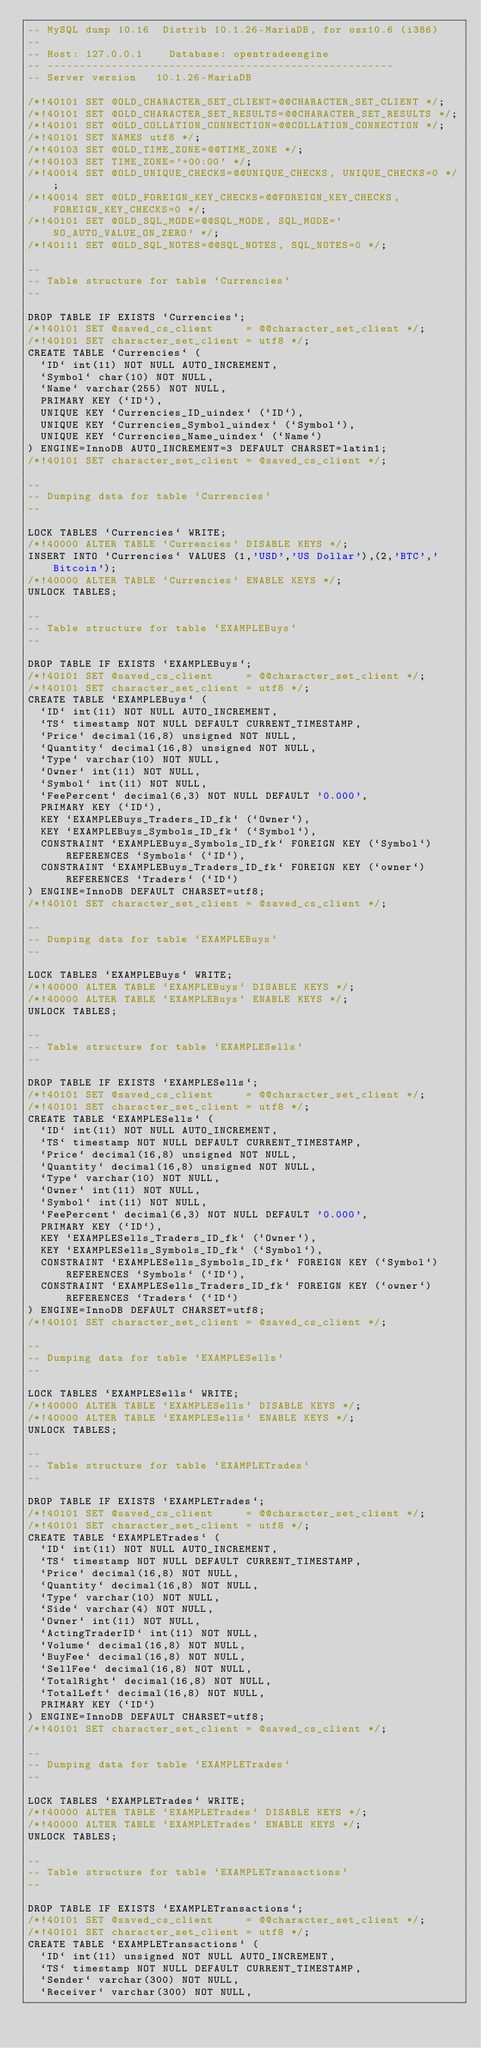Convert code to text. <code><loc_0><loc_0><loc_500><loc_500><_SQL_>-- MySQL dump 10.16  Distrib 10.1.26-MariaDB, for osx10.6 (i386)
--
-- Host: 127.0.0.1    Database: opentradeengine
-- ------------------------------------------------------
-- Server version	10.1.26-MariaDB

/*!40101 SET @OLD_CHARACTER_SET_CLIENT=@@CHARACTER_SET_CLIENT */;
/*!40101 SET @OLD_CHARACTER_SET_RESULTS=@@CHARACTER_SET_RESULTS */;
/*!40101 SET @OLD_COLLATION_CONNECTION=@@COLLATION_CONNECTION */;
/*!40101 SET NAMES utf8 */;
/*!40103 SET @OLD_TIME_ZONE=@@TIME_ZONE */;
/*!40103 SET TIME_ZONE='+00:00' */;
/*!40014 SET @OLD_UNIQUE_CHECKS=@@UNIQUE_CHECKS, UNIQUE_CHECKS=0 */;
/*!40014 SET @OLD_FOREIGN_KEY_CHECKS=@@FOREIGN_KEY_CHECKS, FOREIGN_KEY_CHECKS=0 */;
/*!40101 SET @OLD_SQL_MODE=@@SQL_MODE, SQL_MODE='NO_AUTO_VALUE_ON_ZERO' */;
/*!40111 SET @OLD_SQL_NOTES=@@SQL_NOTES, SQL_NOTES=0 */;

--
-- Table structure for table `Currencies`
--

DROP TABLE IF EXISTS `Currencies`;
/*!40101 SET @saved_cs_client     = @@character_set_client */;
/*!40101 SET character_set_client = utf8 */;
CREATE TABLE `Currencies` (
  `ID` int(11) NOT NULL AUTO_INCREMENT,
  `Symbol` char(10) NOT NULL,
  `Name` varchar(255) NOT NULL,
  PRIMARY KEY (`ID`),
  UNIQUE KEY `Currencies_ID_uindex` (`ID`),
  UNIQUE KEY `Currencies_Symbol_uindex` (`Symbol`),
  UNIQUE KEY `Currencies_Name_uindex` (`Name`)
) ENGINE=InnoDB AUTO_INCREMENT=3 DEFAULT CHARSET=latin1;
/*!40101 SET character_set_client = @saved_cs_client */;

--
-- Dumping data for table `Currencies`
--

LOCK TABLES `Currencies` WRITE;
/*!40000 ALTER TABLE `Currencies` DISABLE KEYS */;
INSERT INTO `Currencies` VALUES (1,'USD','US Dollar'),(2,'BTC','Bitcoin');
/*!40000 ALTER TABLE `Currencies` ENABLE KEYS */;
UNLOCK TABLES;

--
-- Table structure for table `EXAMPLEBuys`
--

DROP TABLE IF EXISTS `EXAMPLEBuys`;
/*!40101 SET @saved_cs_client     = @@character_set_client */;
/*!40101 SET character_set_client = utf8 */;
CREATE TABLE `EXAMPLEBuys` (
  `ID` int(11) NOT NULL AUTO_INCREMENT,
  `TS` timestamp NOT NULL DEFAULT CURRENT_TIMESTAMP,
  `Price` decimal(16,8) unsigned NOT NULL,
  `Quantity` decimal(16,8) unsigned NOT NULL,
  `Type` varchar(10) NOT NULL,
  `Owner` int(11) NOT NULL,
  `Symbol` int(11) NOT NULL,
  `FeePercent` decimal(6,3) NOT NULL DEFAULT '0.000',
  PRIMARY KEY (`ID`),
  KEY `EXAMPLEBuys_Traders_ID_fk` (`Owner`),
  KEY `EXAMPLEBuys_Symbols_ID_fk` (`Symbol`),
  CONSTRAINT `EXAMPLEBuys_Symbols_ID_fk` FOREIGN KEY (`Symbol`) REFERENCES `Symbols` (`ID`),
  CONSTRAINT `EXAMPLEBuys_Traders_ID_fk` FOREIGN KEY (`owner`) REFERENCES `Traders` (`ID`)
) ENGINE=InnoDB DEFAULT CHARSET=utf8;
/*!40101 SET character_set_client = @saved_cs_client */;

--
-- Dumping data for table `EXAMPLEBuys`
--

LOCK TABLES `EXAMPLEBuys` WRITE;
/*!40000 ALTER TABLE `EXAMPLEBuys` DISABLE KEYS */;
/*!40000 ALTER TABLE `EXAMPLEBuys` ENABLE KEYS */;
UNLOCK TABLES;

--
-- Table structure for table `EXAMPLESells`
--

DROP TABLE IF EXISTS `EXAMPLESells`;
/*!40101 SET @saved_cs_client     = @@character_set_client */;
/*!40101 SET character_set_client = utf8 */;
CREATE TABLE `EXAMPLESells` (
  `ID` int(11) NOT NULL AUTO_INCREMENT,
  `TS` timestamp NOT NULL DEFAULT CURRENT_TIMESTAMP,
  `Price` decimal(16,8) unsigned NOT NULL,
  `Quantity` decimal(16,8) unsigned NOT NULL,
  `Type` varchar(10) NOT NULL,
  `Owner` int(11) NOT NULL,
  `Symbol` int(11) NOT NULL,
  `FeePercent` decimal(6,3) NOT NULL DEFAULT '0.000',
  PRIMARY KEY (`ID`),
  KEY `EXAMPLESells_Traders_ID_fk` (`Owner`),
  KEY `EXAMPLESells_Symbols_ID_fk` (`Symbol`),
  CONSTRAINT `EXAMPLESells_Symbols_ID_fk` FOREIGN KEY (`Symbol`) REFERENCES `Symbols` (`ID`),
  CONSTRAINT `EXAMPLESells_Traders_ID_fk` FOREIGN KEY (`owner`) REFERENCES `Traders` (`ID`)
) ENGINE=InnoDB DEFAULT CHARSET=utf8;
/*!40101 SET character_set_client = @saved_cs_client */;

--
-- Dumping data for table `EXAMPLESells`
--

LOCK TABLES `EXAMPLESells` WRITE;
/*!40000 ALTER TABLE `EXAMPLESells` DISABLE KEYS */;
/*!40000 ALTER TABLE `EXAMPLESells` ENABLE KEYS */;
UNLOCK TABLES;

--
-- Table structure for table `EXAMPLETrades`
--

DROP TABLE IF EXISTS `EXAMPLETrades`;
/*!40101 SET @saved_cs_client     = @@character_set_client */;
/*!40101 SET character_set_client = utf8 */;
CREATE TABLE `EXAMPLETrades` (
  `ID` int(11) NOT NULL AUTO_INCREMENT,
  `TS` timestamp NOT NULL DEFAULT CURRENT_TIMESTAMP,
  `Price` decimal(16,8) NOT NULL,
  `Quantity` decimal(16,8) NOT NULL,
  `Type` varchar(10) NOT NULL,
  `Side` varchar(4) NOT NULL,
  `Owner` int(11) NOT NULL,
  `ActingTraderID` int(11) NOT NULL,
  `Volume` decimal(16,8) NOT NULL,
  `BuyFee` decimal(16,8) NOT NULL,
  `SellFee` decimal(16,8) NOT NULL,
  `TotalRight` decimal(16,8) NOT NULL,
  `TotalLeft` decimal(16,8) NOT NULL,
  PRIMARY KEY (`ID`)
) ENGINE=InnoDB DEFAULT CHARSET=utf8;
/*!40101 SET character_set_client = @saved_cs_client */;

--
-- Dumping data for table `EXAMPLETrades`
--

LOCK TABLES `EXAMPLETrades` WRITE;
/*!40000 ALTER TABLE `EXAMPLETrades` DISABLE KEYS */;
/*!40000 ALTER TABLE `EXAMPLETrades` ENABLE KEYS */;
UNLOCK TABLES;

--
-- Table structure for table `EXAMPLETransactions`
--

DROP TABLE IF EXISTS `EXAMPLETransactions`;
/*!40101 SET @saved_cs_client     = @@character_set_client */;
/*!40101 SET character_set_client = utf8 */;
CREATE TABLE `EXAMPLETransactions` (
  `ID` int(11) unsigned NOT NULL AUTO_INCREMENT,
  `TS` timestamp NOT NULL DEFAULT CURRENT_TIMESTAMP,
  `Sender` varchar(300) NOT NULL,
  `Receiver` varchar(300) NOT NULL,</code> 